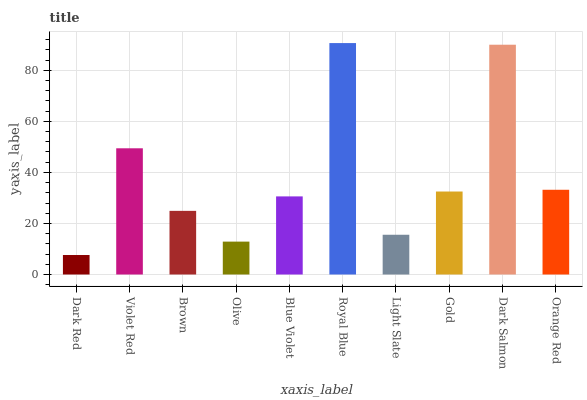Is Dark Red the minimum?
Answer yes or no. Yes. Is Royal Blue the maximum?
Answer yes or no. Yes. Is Violet Red the minimum?
Answer yes or no. No. Is Violet Red the maximum?
Answer yes or no. No. Is Violet Red greater than Dark Red?
Answer yes or no. Yes. Is Dark Red less than Violet Red?
Answer yes or no. Yes. Is Dark Red greater than Violet Red?
Answer yes or no. No. Is Violet Red less than Dark Red?
Answer yes or no. No. Is Gold the high median?
Answer yes or no. Yes. Is Blue Violet the low median?
Answer yes or no. Yes. Is Royal Blue the high median?
Answer yes or no. No. Is Gold the low median?
Answer yes or no. No. 